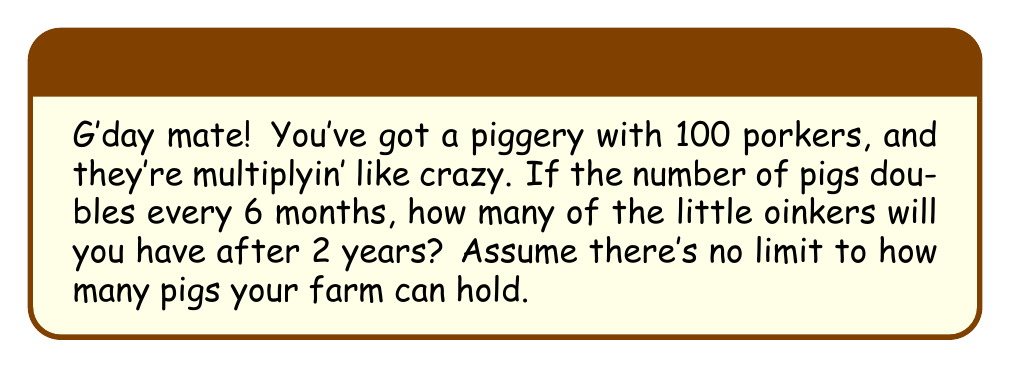Show me your answer to this math problem. Alright, let's break this down into bite-sized chunks:

1) First, we need to figure out how many times the pig population doubles in 2 years.
   - 2 years = 24 months
   - The population doubles every 6 months
   - So, in 2 years, it doubles 24 ÷ 6 = 4 times

2) Now, let's think about what happens each time the population doubles:
   - Start with 100 pigs
   - After 6 months: 100 × 2 = 200 pigs
   - After 12 months: 200 × 2 = 400 pigs
   - After 18 months: 400 × 2 = 800 pigs
   - After 24 months: 800 × 2 = 1600 pigs

3) We can write this as a mathematical equation:
   $$ \text{Final number of pigs} = 100 \times 2^4 $$

4) To solve this:
   $$ 100 \times 2^4 = 100 \times 16 = 1600 $$

So, after 2 years, you'll have 1600 pigs on your hands!

5) If we wanted to get fancy, we could use a formula for exponential growth:
   $$ P(t) = P_0 \times (1 + r)^t $$
   Where $P_0$ is the initial population, $r$ is the growth rate, and $t$ is the number of time periods.

   In this case:
   $P_0 = 100$
   $r = 1$ (100% growth, or doubling)
   $t = 4$ (number of 6-month periods in 2 years)

   $$ P(4) = 100 \times (1 + 1)^4 = 100 \times 2^4 = 1600 $$

This gives us the same answer as our step-by-step method.
Answer: 1600 pigs 